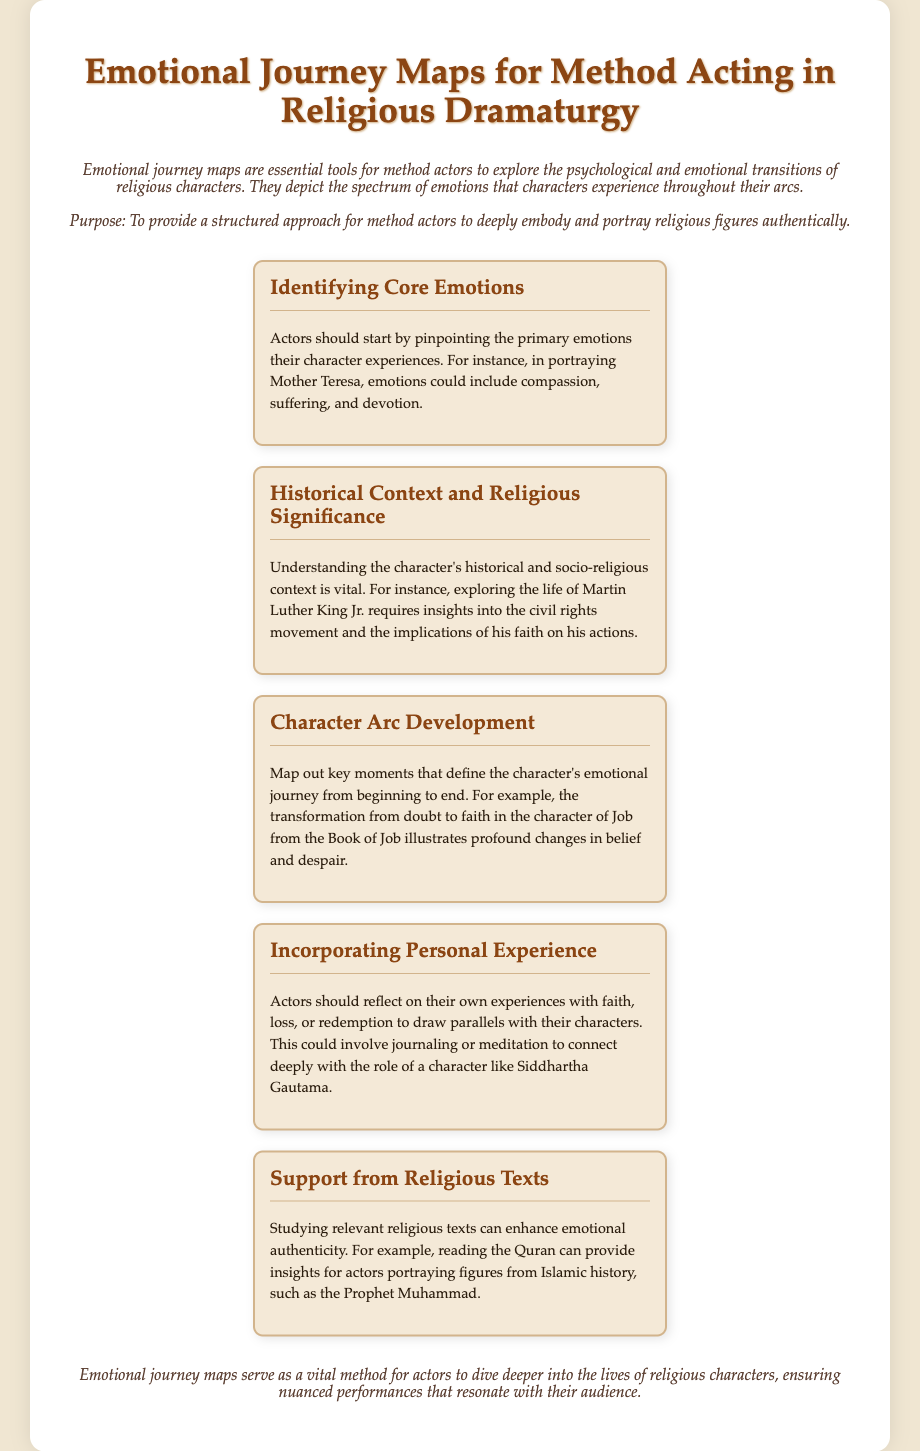What is the title of the document? The title is prominently displayed in the header section of the document.
Answer: Emotional Journey Maps for Method Acting in Religious Dramaturgy What is the purpose of emotional journey maps? The purpose is stated in the introduction as a structured approach for method actors.
Answer: To provide a structured approach for method actors What character's emotions are identified in the first menu item? The first menu item focuses on specific emotions related to a well-known religious figure.
Answer: Mother Teresa Which historical context is mentioned regarding Martin Luther King Jr.? This context highlights the societal implications of the character's faith and actions.
Answer: Civil rights movement What does the character arc develop from in the Book of Job? The document explains the transformation journey of a particular character in the religious text.
Answer: Doubt to faith What personal experiences should actors reflect on? This aspect emphasizes the importance of personal history in connecting with the character.
Answer: Faith, loss, or redemption What type of support is recommended for enhancing emotional authenticity? This refers to utilizing specific texts to gain insights into characters.
Answer: Religious texts What is the overall outcome of using emotional journey maps? The conclusion summarizes the ultimate benefit of employing this method in performance.
Answer: Nuanced performances 